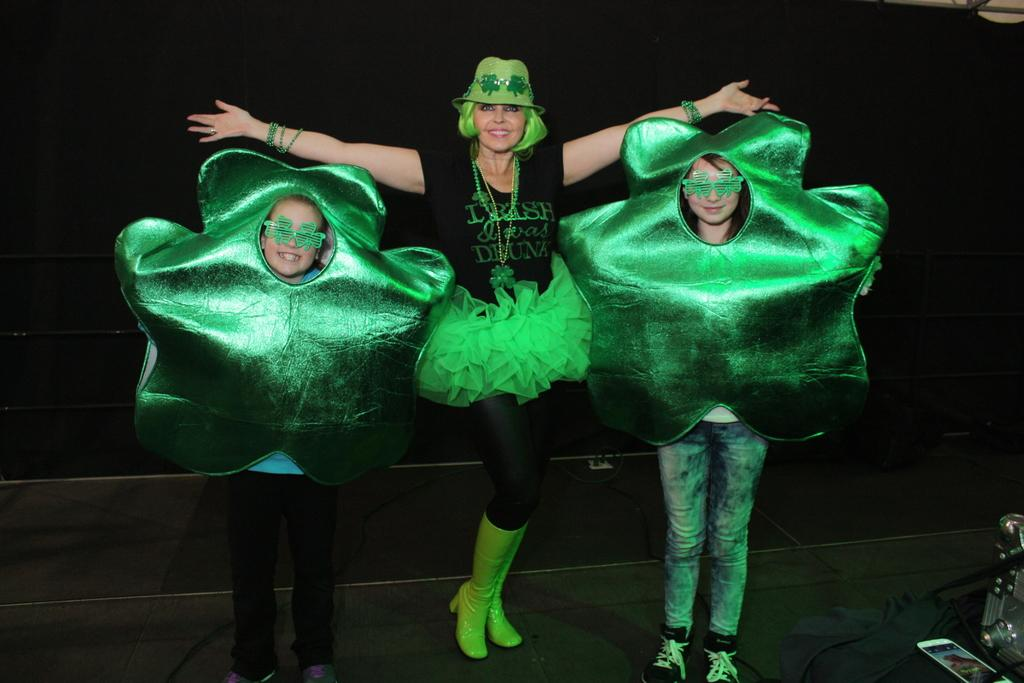How many people are present in the image? There are three people in the image. What is the position of the people in the image? The people are on the ground. What else can be seen in the image besides the people? There are objects in the image. Can you describe the background of the image? The background of the image is dark. What type of liquid can be seen spilling from the railway in the image? There is no railway or liquid present in the image. 